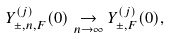Convert formula to latex. <formula><loc_0><loc_0><loc_500><loc_500>Y ^ { ( j ) } _ { \pm , n , F } ( 0 ) \underset { n \to \infty } { \to } Y ^ { ( j ) } _ { \pm , F } ( 0 ) ,</formula> 